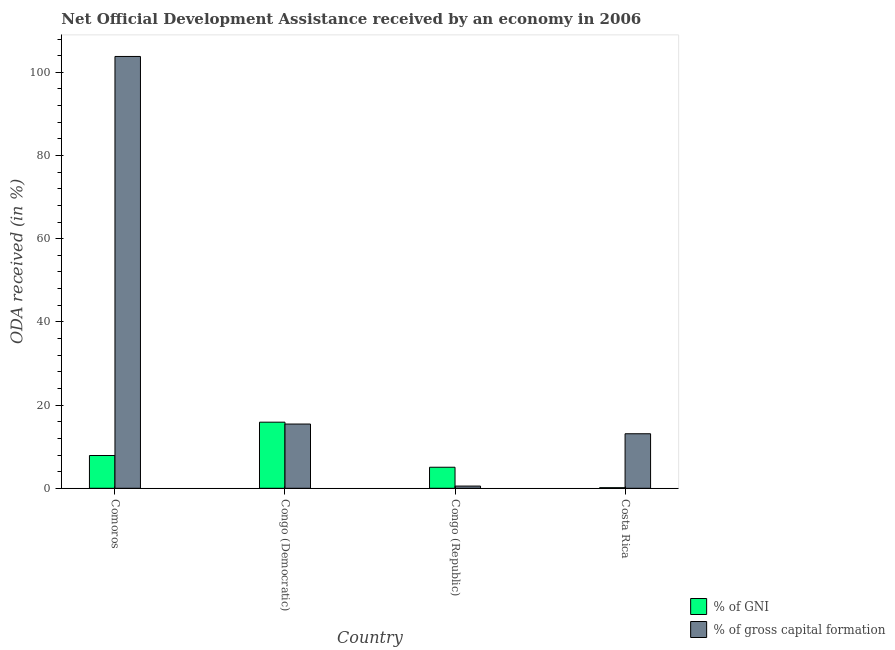How many different coloured bars are there?
Give a very brief answer. 2. How many groups of bars are there?
Your answer should be compact. 4. Are the number of bars on each tick of the X-axis equal?
Provide a succinct answer. Yes. How many bars are there on the 3rd tick from the left?
Your answer should be very brief. 2. What is the oda received as percentage of gni in Costa Rica?
Offer a terse response. 0.14. Across all countries, what is the maximum oda received as percentage of gni?
Your response must be concise. 15.89. Across all countries, what is the minimum oda received as percentage of gni?
Ensure brevity in your answer.  0.14. In which country was the oda received as percentage of gross capital formation maximum?
Give a very brief answer. Comoros. What is the total oda received as percentage of gni in the graph?
Provide a short and direct response. 28.97. What is the difference between the oda received as percentage of gross capital formation in Congo (Democratic) and that in Costa Rica?
Make the answer very short. 2.34. What is the difference between the oda received as percentage of gni in Comoros and the oda received as percentage of gross capital formation in Congo (Democratic)?
Offer a terse response. -7.57. What is the average oda received as percentage of gross capital formation per country?
Your response must be concise. 33.22. What is the difference between the oda received as percentage of gross capital formation and oda received as percentage of gni in Congo (Republic)?
Your response must be concise. -4.53. What is the ratio of the oda received as percentage of gni in Comoros to that in Congo (Democratic)?
Provide a short and direct response. 0.5. Is the oda received as percentage of gni in Congo (Democratic) less than that in Costa Rica?
Make the answer very short. No. Is the difference between the oda received as percentage of gross capital formation in Comoros and Congo (Republic) greater than the difference between the oda received as percentage of gni in Comoros and Congo (Republic)?
Your answer should be compact. Yes. What is the difference between the highest and the second highest oda received as percentage of gross capital formation?
Your response must be concise. 88.36. What is the difference between the highest and the lowest oda received as percentage of gni?
Ensure brevity in your answer.  15.75. What does the 2nd bar from the left in Congo (Democratic) represents?
Your answer should be compact. % of gross capital formation. What does the 1st bar from the right in Costa Rica represents?
Offer a terse response. % of gross capital formation. How many bars are there?
Your answer should be compact. 8. How are the legend labels stacked?
Ensure brevity in your answer.  Vertical. What is the title of the graph?
Provide a succinct answer. Net Official Development Assistance received by an economy in 2006. Does "Quasi money growth" appear as one of the legend labels in the graph?
Offer a terse response. No. What is the label or title of the Y-axis?
Keep it short and to the point. ODA received (in %). What is the ODA received (in %) of % of GNI in Comoros?
Provide a succinct answer. 7.88. What is the ODA received (in %) of % of gross capital formation in Comoros?
Give a very brief answer. 103.81. What is the ODA received (in %) of % of GNI in Congo (Democratic)?
Your answer should be compact. 15.89. What is the ODA received (in %) of % of gross capital formation in Congo (Democratic)?
Provide a succinct answer. 15.44. What is the ODA received (in %) of % of GNI in Congo (Republic)?
Your response must be concise. 5.06. What is the ODA received (in %) of % of gross capital formation in Congo (Republic)?
Give a very brief answer. 0.53. What is the ODA received (in %) of % of GNI in Costa Rica?
Ensure brevity in your answer.  0.14. What is the ODA received (in %) of % of gross capital formation in Costa Rica?
Provide a succinct answer. 13.11. Across all countries, what is the maximum ODA received (in %) in % of GNI?
Offer a very short reply. 15.89. Across all countries, what is the maximum ODA received (in %) of % of gross capital formation?
Provide a short and direct response. 103.81. Across all countries, what is the minimum ODA received (in %) of % of GNI?
Your answer should be compact. 0.14. Across all countries, what is the minimum ODA received (in %) of % of gross capital formation?
Your response must be concise. 0.53. What is the total ODA received (in %) in % of GNI in the graph?
Your answer should be compact. 28.97. What is the total ODA received (in %) in % of gross capital formation in the graph?
Make the answer very short. 132.89. What is the difference between the ODA received (in %) of % of GNI in Comoros and that in Congo (Democratic)?
Give a very brief answer. -8.01. What is the difference between the ODA received (in %) in % of gross capital formation in Comoros and that in Congo (Democratic)?
Make the answer very short. 88.36. What is the difference between the ODA received (in %) in % of GNI in Comoros and that in Congo (Republic)?
Ensure brevity in your answer.  2.82. What is the difference between the ODA received (in %) in % of gross capital formation in Comoros and that in Congo (Republic)?
Give a very brief answer. 103.27. What is the difference between the ODA received (in %) of % of GNI in Comoros and that in Costa Rica?
Provide a short and direct response. 7.74. What is the difference between the ODA received (in %) in % of gross capital formation in Comoros and that in Costa Rica?
Provide a succinct answer. 90.7. What is the difference between the ODA received (in %) of % of GNI in Congo (Democratic) and that in Congo (Republic)?
Offer a terse response. 10.83. What is the difference between the ODA received (in %) of % of gross capital formation in Congo (Democratic) and that in Congo (Republic)?
Offer a very short reply. 14.91. What is the difference between the ODA received (in %) in % of GNI in Congo (Democratic) and that in Costa Rica?
Make the answer very short. 15.75. What is the difference between the ODA received (in %) in % of gross capital formation in Congo (Democratic) and that in Costa Rica?
Keep it short and to the point. 2.34. What is the difference between the ODA received (in %) in % of GNI in Congo (Republic) and that in Costa Rica?
Offer a terse response. 4.92. What is the difference between the ODA received (in %) of % of gross capital formation in Congo (Republic) and that in Costa Rica?
Offer a very short reply. -12.58. What is the difference between the ODA received (in %) in % of GNI in Comoros and the ODA received (in %) in % of gross capital formation in Congo (Democratic)?
Make the answer very short. -7.57. What is the difference between the ODA received (in %) of % of GNI in Comoros and the ODA received (in %) of % of gross capital formation in Congo (Republic)?
Make the answer very short. 7.35. What is the difference between the ODA received (in %) in % of GNI in Comoros and the ODA received (in %) in % of gross capital formation in Costa Rica?
Give a very brief answer. -5.23. What is the difference between the ODA received (in %) of % of GNI in Congo (Democratic) and the ODA received (in %) of % of gross capital formation in Congo (Republic)?
Ensure brevity in your answer.  15.36. What is the difference between the ODA received (in %) in % of GNI in Congo (Democratic) and the ODA received (in %) in % of gross capital formation in Costa Rica?
Offer a terse response. 2.78. What is the difference between the ODA received (in %) of % of GNI in Congo (Republic) and the ODA received (in %) of % of gross capital formation in Costa Rica?
Make the answer very short. -8.05. What is the average ODA received (in %) of % of GNI per country?
Ensure brevity in your answer.  7.24. What is the average ODA received (in %) in % of gross capital formation per country?
Your answer should be very brief. 33.22. What is the difference between the ODA received (in %) of % of GNI and ODA received (in %) of % of gross capital formation in Comoros?
Offer a terse response. -95.93. What is the difference between the ODA received (in %) in % of GNI and ODA received (in %) in % of gross capital formation in Congo (Democratic)?
Ensure brevity in your answer.  0.45. What is the difference between the ODA received (in %) of % of GNI and ODA received (in %) of % of gross capital formation in Congo (Republic)?
Your answer should be very brief. 4.53. What is the difference between the ODA received (in %) in % of GNI and ODA received (in %) in % of gross capital formation in Costa Rica?
Provide a short and direct response. -12.97. What is the ratio of the ODA received (in %) of % of GNI in Comoros to that in Congo (Democratic)?
Keep it short and to the point. 0.5. What is the ratio of the ODA received (in %) in % of gross capital formation in Comoros to that in Congo (Democratic)?
Your answer should be very brief. 6.72. What is the ratio of the ODA received (in %) of % of GNI in Comoros to that in Congo (Republic)?
Make the answer very short. 1.56. What is the ratio of the ODA received (in %) of % of gross capital formation in Comoros to that in Congo (Republic)?
Offer a very short reply. 194.81. What is the ratio of the ODA received (in %) in % of GNI in Comoros to that in Costa Rica?
Provide a short and direct response. 55.97. What is the ratio of the ODA received (in %) of % of gross capital formation in Comoros to that in Costa Rica?
Keep it short and to the point. 7.92. What is the ratio of the ODA received (in %) of % of GNI in Congo (Democratic) to that in Congo (Republic)?
Your response must be concise. 3.14. What is the ratio of the ODA received (in %) in % of gross capital formation in Congo (Democratic) to that in Congo (Republic)?
Your response must be concise. 28.98. What is the ratio of the ODA received (in %) of % of GNI in Congo (Democratic) to that in Costa Rica?
Provide a succinct answer. 112.91. What is the ratio of the ODA received (in %) of % of gross capital formation in Congo (Democratic) to that in Costa Rica?
Your answer should be compact. 1.18. What is the ratio of the ODA received (in %) in % of GNI in Congo (Republic) to that in Costa Rica?
Your answer should be very brief. 35.95. What is the ratio of the ODA received (in %) of % of gross capital formation in Congo (Republic) to that in Costa Rica?
Keep it short and to the point. 0.04. What is the difference between the highest and the second highest ODA received (in %) of % of GNI?
Offer a terse response. 8.01. What is the difference between the highest and the second highest ODA received (in %) in % of gross capital formation?
Provide a succinct answer. 88.36. What is the difference between the highest and the lowest ODA received (in %) of % of GNI?
Your answer should be very brief. 15.75. What is the difference between the highest and the lowest ODA received (in %) in % of gross capital formation?
Offer a very short reply. 103.27. 